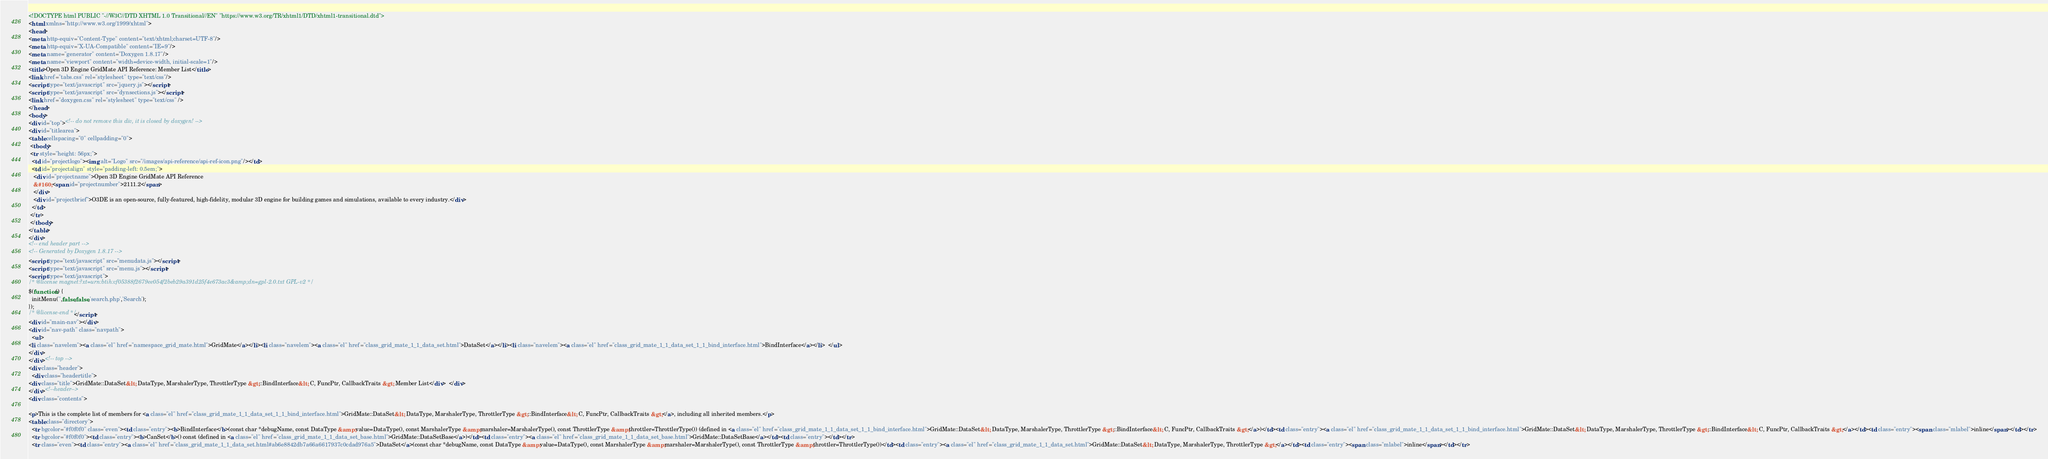Convert code to text. <code><loc_0><loc_0><loc_500><loc_500><_HTML_><!DOCTYPE html PUBLIC "-//W3C//DTD XHTML 1.0 Transitional//EN" "https://www.w3.org/TR/xhtml1/DTD/xhtml1-transitional.dtd">
<html xmlns="http://www.w3.org/1999/xhtml">
<head>
<meta http-equiv="Content-Type" content="text/xhtml;charset=UTF-8"/>
<meta http-equiv="X-UA-Compatible" content="IE=9"/>
<meta name="generator" content="Doxygen 1.8.17"/>
<meta name="viewport" content="width=device-width, initial-scale=1"/>
<title>Open 3D Engine GridMate API Reference: Member List</title>
<link href="tabs.css" rel="stylesheet" type="text/css"/>
<script type="text/javascript" src="jquery.js"></script>
<script type="text/javascript" src="dynsections.js"></script>
<link href="doxygen.css" rel="stylesheet" type="text/css" />
</head>
<body>
<div id="top"><!-- do not remove this div, it is closed by doxygen! -->
<div id="titlearea">
<table cellspacing="0" cellpadding="0">
 <tbody>
 <tr style="height: 56px;">
  <td id="projectlogo"><img alt="Logo" src="/images/api-reference/api-ref-icon.png"/></td>
  <td id="projectalign" style="padding-left: 0.5em;">
   <div id="projectname">Open 3D Engine GridMate API Reference
   &#160;<span id="projectnumber">2111.2</span>
   </div>
   <div id="projectbrief">O3DE is an open-source, fully-featured, high-fidelity, modular 3D engine for building games and simulations, available to every industry.</div>
  </td>
 </tr>
 </tbody>
</table>
</div>
<!-- end header part -->
<!-- Generated by Doxygen 1.8.17 -->
<script type="text/javascript" src="menudata.js"></script>
<script type="text/javascript" src="menu.js"></script>
<script type="text/javascript">
/* @license magnet:?xt=urn:btih:cf05388f2679ee054f2beb29a391d25f4e673ac3&amp;dn=gpl-2.0.txt GPL-v2 */
$(function() {
  initMenu('',false,false,'search.php','Search');
});
/* @license-end */</script>
<div id="main-nav"></div>
<div id="nav-path" class="navpath">
  <ul>
<li class="navelem"><a class="el" href="namespace_grid_mate.html">GridMate</a></li><li class="navelem"><a class="el" href="class_grid_mate_1_1_data_set.html">DataSet</a></li><li class="navelem"><a class="el" href="class_grid_mate_1_1_data_set_1_1_bind_interface.html">BindInterface</a></li>  </ul>
</div>
</div><!-- top -->
<div class="header">
  <div class="headertitle">
<div class="title">GridMate::DataSet&lt; DataType, MarshalerType, ThrottlerType &gt;::BindInterface&lt; C, FuncPtr, CallbackTraits &gt; Member List</div>  </div>
</div><!--header-->
<div class="contents">

<p>This is the complete list of members for <a class="el" href="class_grid_mate_1_1_data_set_1_1_bind_interface.html">GridMate::DataSet&lt; DataType, MarshalerType, ThrottlerType &gt;::BindInterface&lt; C, FuncPtr, CallbackTraits &gt;</a>, including all inherited members.</p>
<table class="directory">
  <tr bgcolor="#f0f0f0" class="even"><td class="entry"><b>BindInterface</b>(const char *debugName, const DataType &amp;value=DataType(), const MarshalerType &amp;marshaler=MarshalerType(), const ThrottlerType &amp;throttler=ThrottlerType()) (defined in <a class="el" href="class_grid_mate_1_1_data_set_1_1_bind_interface.html">GridMate::DataSet&lt; DataType, MarshalerType, ThrottlerType &gt;::BindInterface&lt; C, FuncPtr, CallbackTraits &gt;</a>)</td><td class="entry"><a class="el" href="class_grid_mate_1_1_data_set_1_1_bind_interface.html">GridMate::DataSet&lt; DataType, MarshalerType, ThrottlerType &gt;::BindInterface&lt; C, FuncPtr, CallbackTraits &gt;</a></td><td class="entry"><span class="mlabel">inline</span></td></tr>
  <tr bgcolor="#f0f0f0"><td class="entry"><b>CanSet</b>() const (defined in <a class="el" href="class_grid_mate_1_1_data_set_base.html">GridMate::DataSetBase</a>)</td><td class="entry"><a class="el" href="class_grid_mate_1_1_data_set_base.html">GridMate::DataSetBase</a></td><td class="entry"></td></tr>
  <tr class="even"><td class="entry"><a class="el" href="class_grid_mate_1_1_data_set.html#ab6e8842db7a66a6617937c0cdad976a5">DataSet</a>(const char *debugName, const DataType &amp;value=DataType(), const MarshalerType &amp;marshaler=MarshalerType(), const ThrottlerType &amp;throttler=ThrottlerType())</td><td class="entry"><a class="el" href="class_grid_mate_1_1_data_set.html">GridMate::DataSet&lt; DataType, MarshalerType, ThrottlerType &gt;</a></td><td class="entry"><span class="mlabel">inline</span></td></tr></code> 